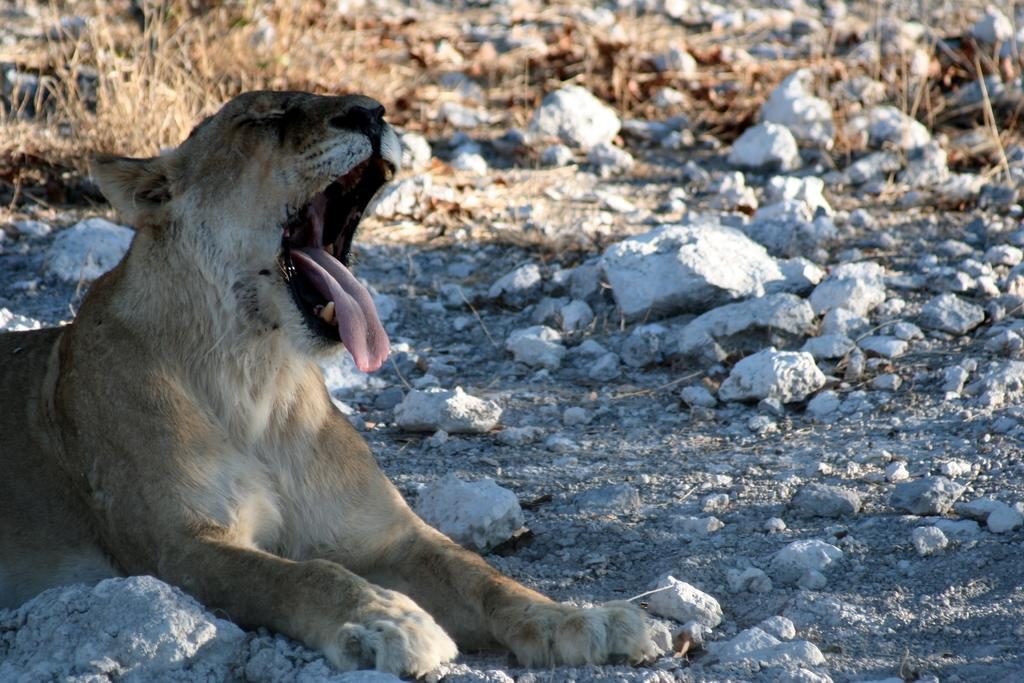What animal is on the left side of the image? There is a tiger on the left side of the image. What type of terrain is visible at the bottom of the image? There are rocks at the bottom of the image. What type of vegetation can be seen in the image? There is dried grass in the image. What type of church can be seen in the image? There is no church present in the image; it features a tiger, rocks, and dried grass. What is the tiger's stomach doing in the image? The tiger's stomach is not visible in the image, and therefore its actions cannot be described. 